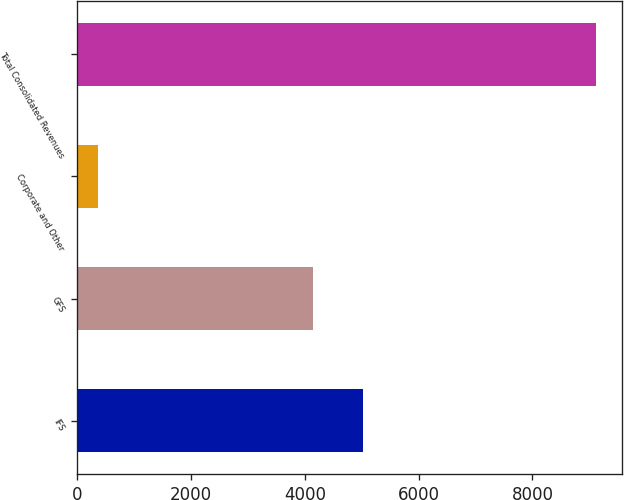Convert chart to OTSL. <chart><loc_0><loc_0><loc_500><loc_500><bar_chart><fcel>IFS<fcel>GFS<fcel>Corporate and Other<fcel>Total Consolidated Revenues<nl><fcel>5014.8<fcel>4138<fcel>355<fcel>9123<nl></chart> 